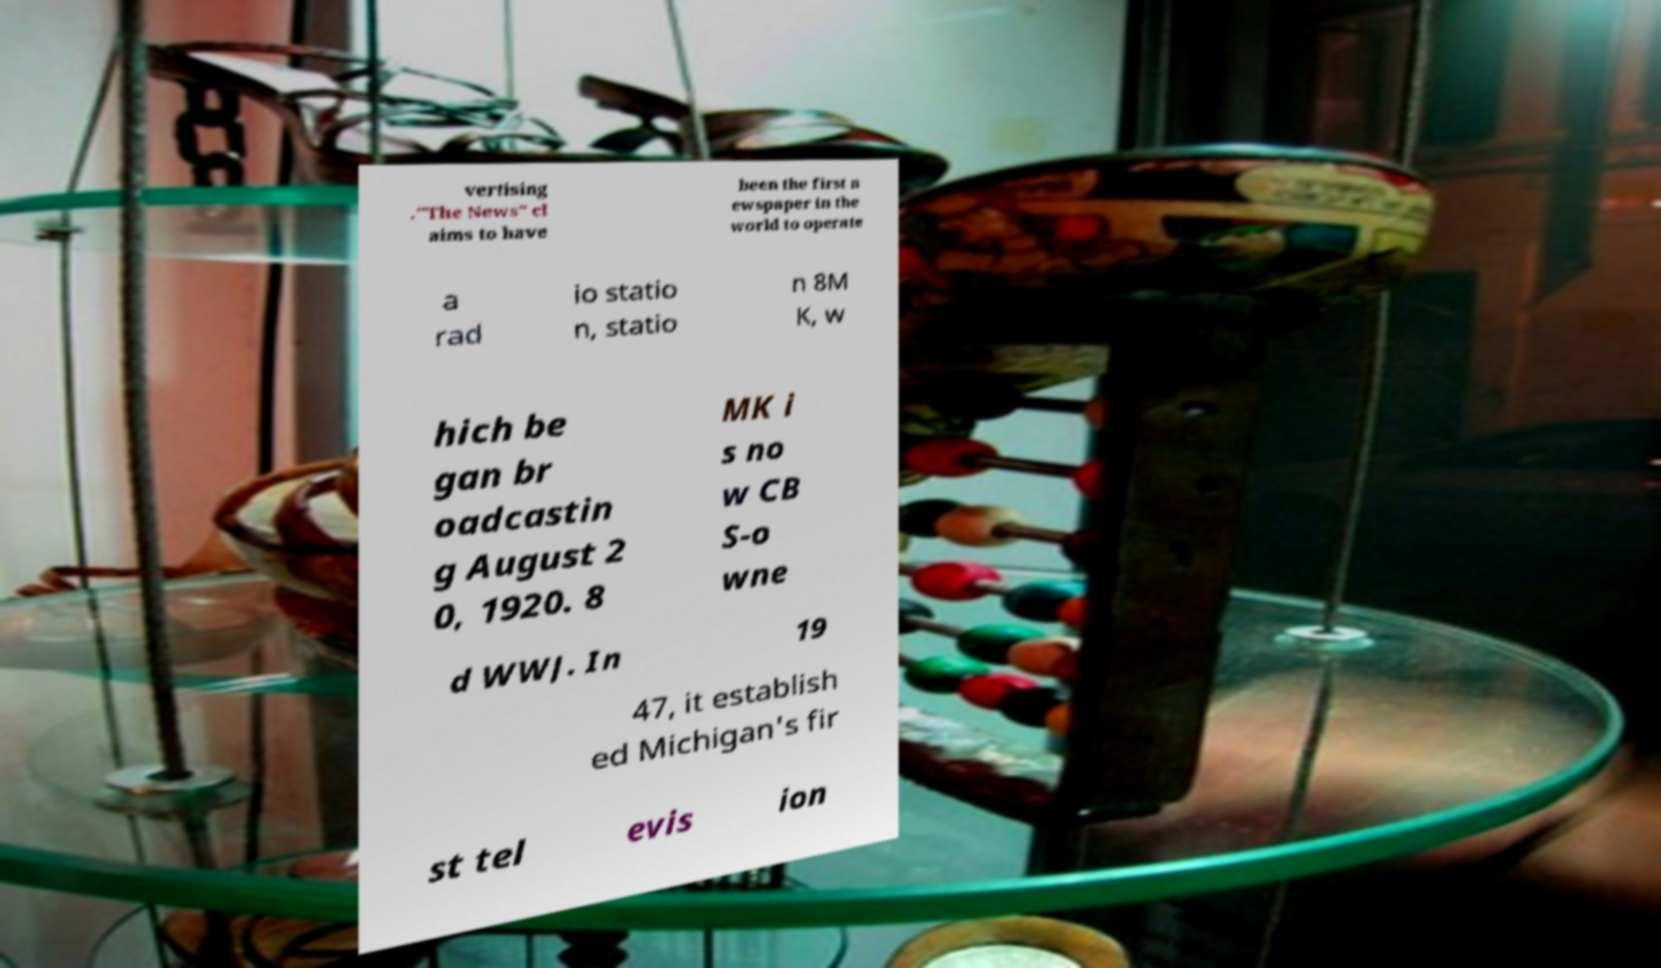Could you assist in decoding the text presented in this image and type it out clearly? vertising ."The News" cl aims to have been the first n ewspaper in the world to operate a rad io statio n, statio n 8M K, w hich be gan br oadcastin g August 2 0, 1920. 8 MK i s no w CB S-o wne d WWJ. In 19 47, it establish ed Michigan's fir st tel evis ion 